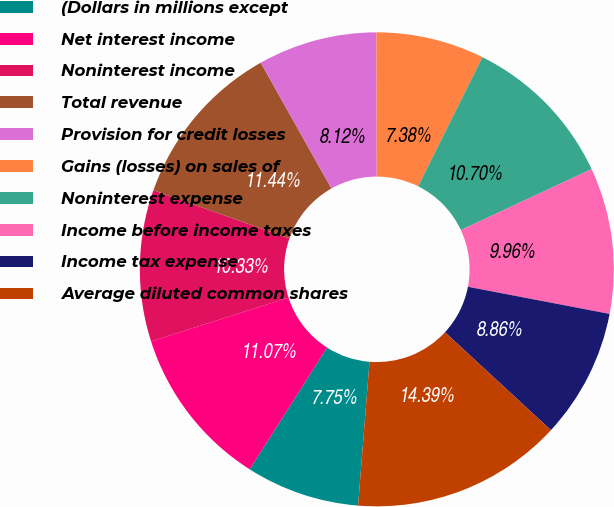Convert chart. <chart><loc_0><loc_0><loc_500><loc_500><pie_chart><fcel>(Dollars in millions except<fcel>Net interest income<fcel>Noninterest income<fcel>Total revenue<fcel>Provision for credit losses<fcel>Gains (losses) on sales of<fcel>Noninterest expense<fcel>Income before income taxes<fcel>Income tax expense<fcel>Average diluted common shares<nl><fcel>7.75%<fcel>11.07%<fcel>10.33%<fcel>11.44%<fcel>8.12%<fcel>7.38%<fcel>10.7%<fcel>9.96%<fcel>8.86%<fcel>14.39%<nl></chart> 